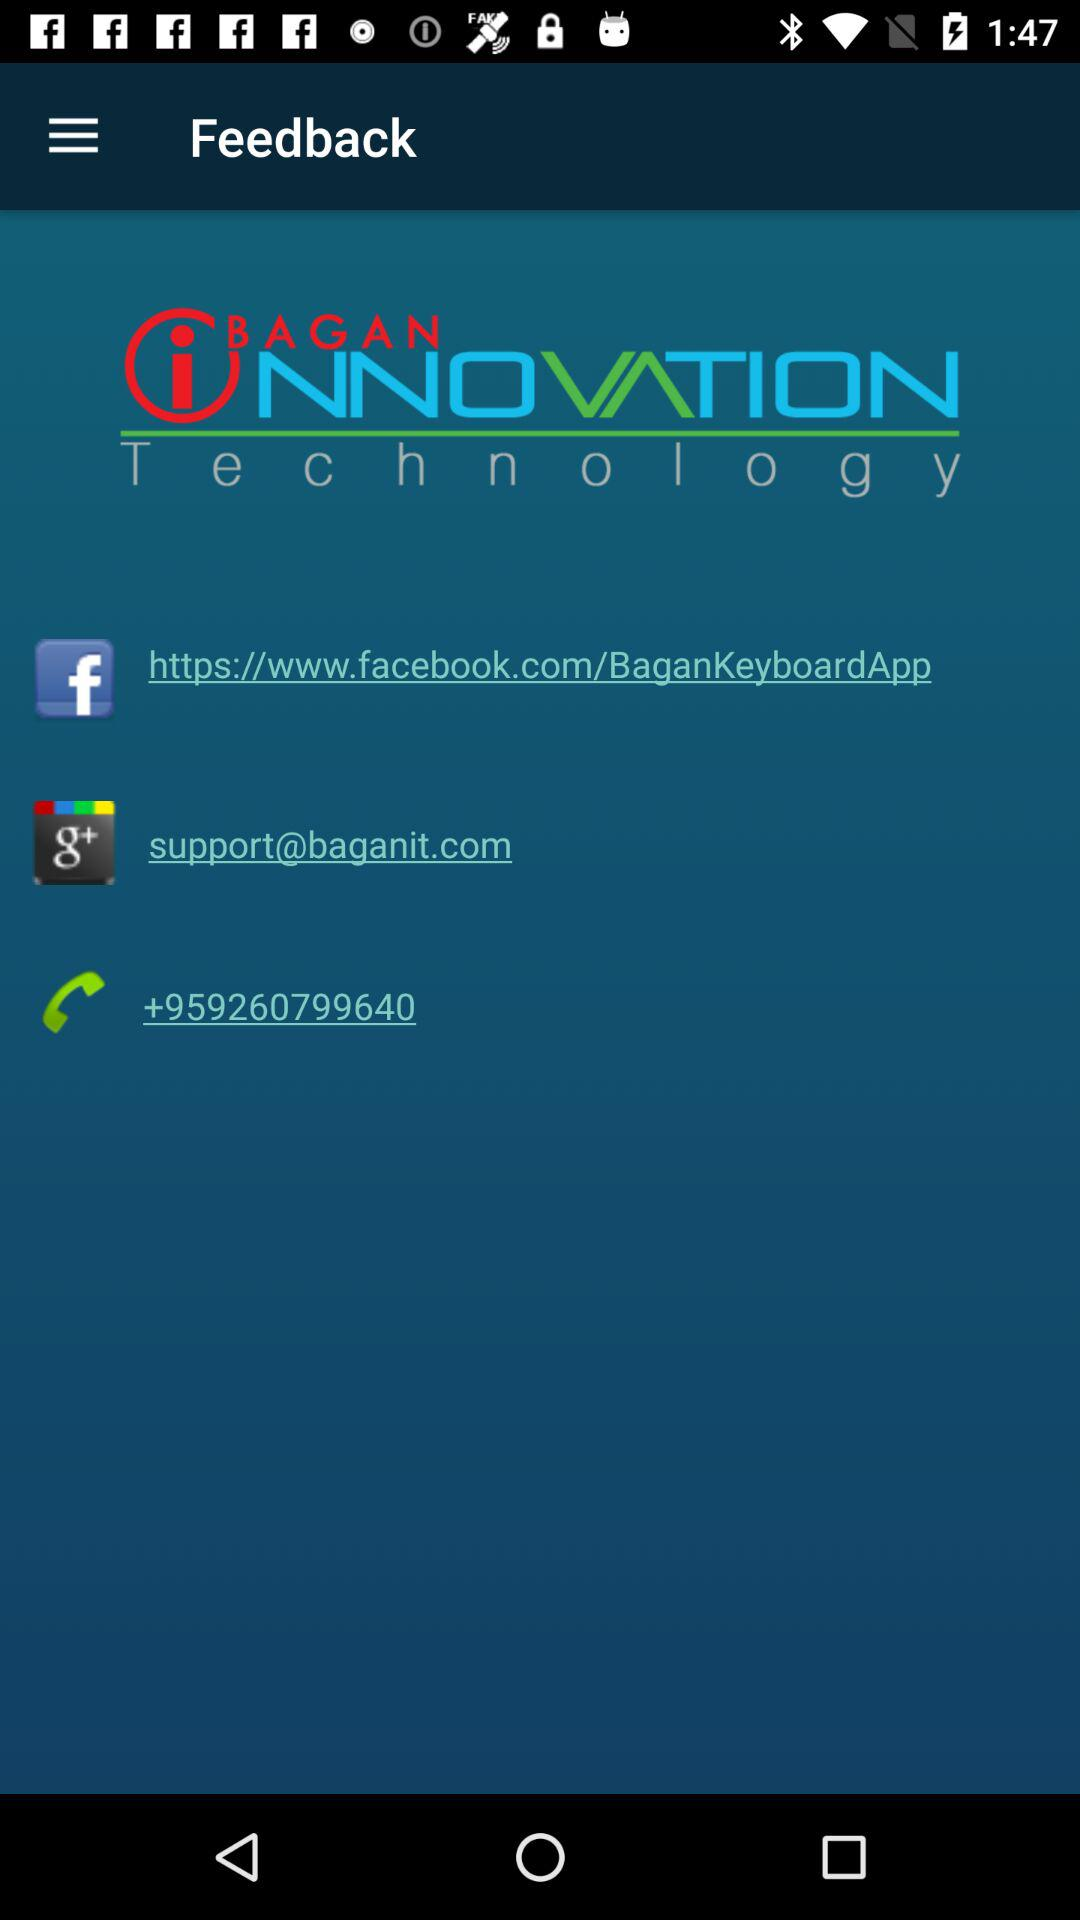What is the provided "Facebook" link? The provided "Facebook" link is https://www.facebook.com/BaganKeyboardApp. 